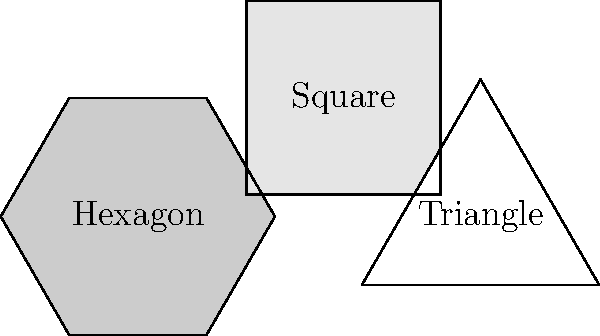For a tessellating pattern in your garden pathway, you decide to use regular hexagons, squares, and equilateral triangles. If the side length of each polygon is 1 meter, and you want to cover an area of 100 square meters, how many of each shape will you need to create a perfect tessellation without gaps or overlaps? Let's approach this step-by-step:

1) First, we need to calculate the area of each shape:

   Hexagon: $A_h = \frac{3\sqrt{3}}{2}a^2 = \frac{3\sqrt{3}}{2} \approx 2.598$ m²
   Square: $A_s = a^2 = 1$ m²
   Triangle: $A_t = \frac{\sqrt{3}}{4}a^2 = \frac{\sqrt{3}}{4} \approx 0.433$ m²

2) In a perfect tessellation of these shapes, the ratio of hexagons : squares : triangles is 1 : 2 : 1.

3) Let $x$ be the number of hexagons. Then we have $2x$ squares and $x$ triangles.

4) The total area covered should be 100 m²:

   $2.598x + 1(2x) + 0.433x = 100$
   $5.031x = 100$
   $x \approx 19.88$

5) Since we can't have partial shapes, we round up to 20 hexagons.

6) This means we need:
   20 hexagons
   40 squares (2 * 20)
   20 triangles

7) Let's verify the total area:
   $(20 * 2.598) + (40 * 1) + (20 * 0.433) = 51.96 + 40 + 8.66 = 100.62$ m²

This slightly exceeds 100 m² due to rounding, but it ensures complete coverage of the desired area.
Answer: 20 hexagons, 40 squares, 20 triangles 